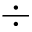<formula> <loc_0><loc_0><loc_500><loc_500>\div</formula> 